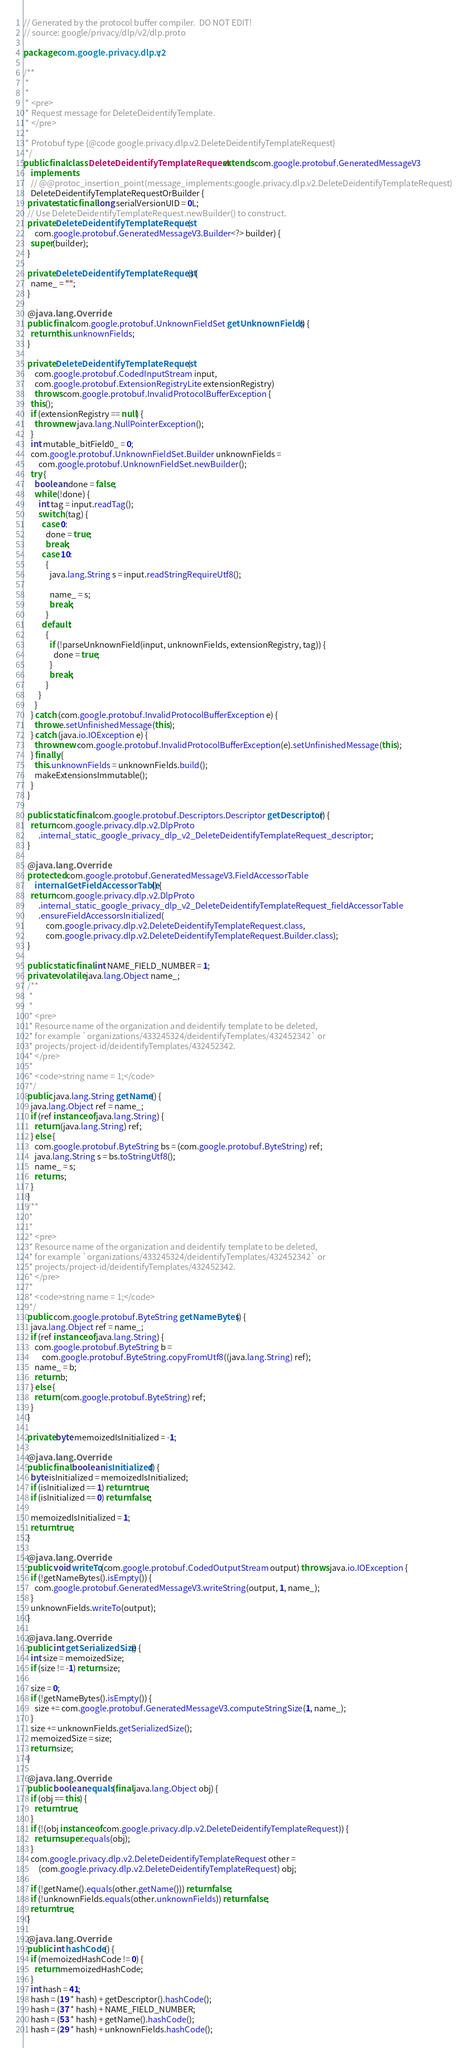<code> <loc_0><loc_0><loc_500><loc_500><_Java_>// Generated by the protocol buffer compiler.  DO NOT EDIT!
// source: google/privacy/dlp/v2/dlp.proto

package com.google.privacy.dlp.v2;

/**
 *
 *
 * <pre>
 * Request message for DeleteDeidentifyTemplate.
 * </pre>
 *
 * Protobuf type {@code google.privacy.dlp.v2.DeleteDeidentifyTemplateRequest}
 */
public final class DeleteDeidentifyTemplateRequest extends com.google.protobuf.GeneratedMessageV3
    implements
    // @@protoc_insertion_point(message_implements:google.privacy.dlp.v2.DeleteDeidentifyTemplateRequest)
    DeleteDeidentifyTemplateRequestOrBuilder {
  private static final long serialVersionUID = 0L;
  // Use DeleteDeidentifyTemplateRequest.newBuilder() to construct.
  private DeleteDeidentifyTemplateRequest(
      com.google.protobuf.GeneratedMessageV3.Builder<?> builder) {
    super(builder);
  }

  private DeleteDeidentifyTemplateRequest() {
    name_ = "";
  }

  @java.lang.Override
  public final com.google.protobuf.UnknownFieldSet getUnknownFields() {
    return this.unknownFields;
  }

  private DeleteDeidentifyTemplateRequest(
      com.google.protobuf.CodedInputStream input,
      com.google.protobuf.ExtensionRegistryLite extensionRegistry)
      throws com.google.protobuf.InvalidProtocolBufferException {
    this();
    if (extensionRegistry == null) {
      throw new java.lang.NullPointerException();
    }
    int mutable_bitField0_ = 0;
    com.google.protobuf.UnknownFieldSet.Builder unknownFields =
        com.google.protobuf.UnknownFieldSet.newBuilder();
    try {
      boolean done = false;
      while (!done) {
        int tag = input.readTag();
        switch (tag) {
          case 0:
            done = true;
            break;
          case 10:
            {
              java.lang.String s = input.readStringRequireUtf8();

              name_ = s;
              break;
            }
          default:
            {
              if (!parseUnknownField(input, unknownFields, extensionRegistry, tag)) {
                done = true;
              }
              break;
            }
        }
      }
    } catch (com.google.protobuf.InvalidProtocolBufferException e) {
      throw e.setUnfinishedMessage(this);
    } catch (java.io.IOException e) {
      throw new com.google.protobuf.InvalidProtocolBufferException(e).setUnfinishedMessage(this);
    } finally {
      this.unknownFields = unknownFields.build();
      makeExtensionsImmutable();
    }
  }

  public static final com.google.protobuf.Descriptors.Descriptor getDescriptor() {
    return com.google.privacy.dlp.v2.DlpProto
        .internal_static_google_privacy_dlp_v2_DeleteDeidentifyTemplateRequest_descriptor;
  }

  @java.lang.Override
  protected com.google.protobuf.GeneratedMessageV3.FieldAccessorTable
      internalGetFieldAccessorTable() {
    return com.google.privacy.dlp.v2.DlpProto
        .internal_static_google_privacy_dlp_v2_DeleteDeidentifyTemplateRequest_fieldAccessorTable
        .ensureFieldAccessorsInitialized(
            com.google.privacy.dlp.v2.DeleteDeidentifyTemplateRequest.class,
            com.google.privacy.dlp.v2.DeleteDeidentifyTemplateRequest.Builder.class);
  }

  public static final int NAME_FIELD_NUMBER = 1;
  private volatile java.lang.Object name_;
  /**
   *
   *
   * <pre>
   * Resource name of the organization and deidentify template to be deleted,
   * for example `organizations/433245324/deidentifyTemplates/432452342` or
   * projects/project-id/deidentifyTemplates/432452342.
   * </pre>
   *
   * <code>string name = 1;</code>
   */
  public java.lang.String getName() {
    java.lang.Object ref = name_;
    if (ref instanceof java.lang.String) {
      return (java.lang.String) ref;
    } else {
      com.google.protobuf.ByteString bs = (com.google.protobuf.ByteString) ref;
      java.lang.String s = bs.toStringUtf8();
      name_ = s;
      return s;
    }
  }
  /**
   *
   *
   * <pre>
   * Resource name of the organization and deidentify template to be deleted,
   * for example `organizations/433245324/deidentifyTemplates/432452342` or
   * projects/project-id/deidentifyTemplates/432452342.
   * </pre>
   *
   * <code>string name = 1;</code>
   */
  public com.google.protobuf.ByteString getNameBytes() {
    java.lang.Object ref = name_;
    if (ref instanceof java.lang.String) {
      com.google.protobuf.ByteString b =
          com.google.protobuf.ByteString.copyFromUtf8((java.lang.String) ref);
      name_ = b;
      return b;
    } else {
      return (com.google.protobuf.ByteString) ref;
    }
  }

  private byte memoizedIsInitialized = -1;

  @java.lang.Override
  public final boolean isInitialized() {
    byte isInitialized = memoizedIsInitialized;
    if (isInitialized == 1) return true;
    if (isInitialized == 0) return false;

    memoizedIsInitialized = 1;
    return true;
  }

  @java.lang.Override
  public void writeTo(com.google.protobuf.CodedOutputStream output) throws java.io.IOException {
    if (!getNameBytes().isEmpty()) {
      com.google.protobuf.GeneratedMessageV3.writeString(output, 1, name_);
    }
    unknownFields.writeTo(output);
  }

  @java.lang.Override
  public int getSerializedSize() {
    int size = memoizedSize;
    if (size != -1) return size;

    size = 0;
    if (!getNameBytes().isEmpty()) {
      size += com.google.protobuf.GeneratedMessageV3.computeStringSize(1, name_);
    }
    size += unknownFields.getSerializedSize();
    memoizedSize = size;
    return size;
  }

  @java.lang.Override
  public boolean equals(final java.lang.Object obj) {
    if (obj == this) {
      return true;
    }
    if (!(obj instanceof com.google.privacy.dlp.v2.DeleteDeidentifyTemplateRequest)) {
      return super.equals(obj);
    }
    com.google.privacy.dlp.v2.DeleteDeidentifyTemplateRequest other =
        (com.google.privacy.dlp.v2.DeleteDeidentifyTemplateRequest) obj;

    if (!getName().equals(other.getName())) return false;
    if (!unknownFields.equals(other.unknownFields)) return false;
    return true;
  }

  @java.lang.Override
  public int hashCode() {
    if (memoizedHashCode != 0) {
      return memoizedHashCode;
    }
    int hash = 41;
    hash = (19 * hash) + getDescriptor().hashCode();
    hash = (37 * hash) + NAME_FIELD_NUMBER;
    hash = (53 * hash) + getName().hashCode();
    hash = (29 * hash) + unknownFields.hashCode();</code> 